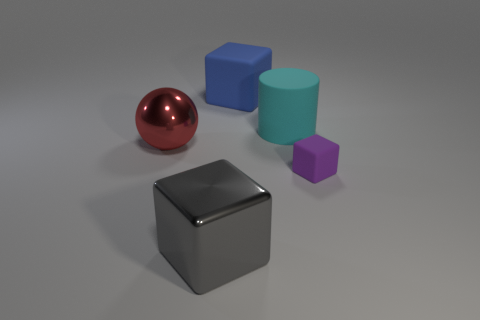Subtract all large cubes. How many cubes are left? 1 Add 3 tiny brown spheres. How many objects exist? 8 Subtract all blocks. How many objects are left? 2 Subtract 1 spheres. How many spheres are left? 0 Add 5 gray objects. How many gray objects are left? 6 Add 4 purple matte cubes. How many purple matte cubes exist? 5 Subtract 0 purple spheres. How many objects are left? 5 Subtract all red cylinders. Subtract all purple spheres. How many cylinders are left? 1 Subtract all purple cylinders. How many brown spheres are left? 0 Subtract all purple metal blocks. Subtract all large metal things. How many objects are left? 3 